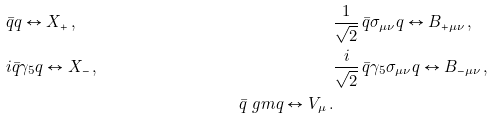Convert formula to latex. <formula><loc_0><loc_0><loc_500><loc_500>& \bar { q } q \leftrightarrow X _ { + } \, , & & \frac { 1 } { \sqrt { 2 } } \, \bar { q } \sigma _ { \mu \nu } q \leftrightarrow B _ { + \mu \nu } \, , \\ & i \bar { q } \gamma _ { 5 } q \leftrightarrow X _ { - } \, , & & \frac { i } { \sqrt { 2 } } \, \bar { q } \gamma _ { 5 } \sigma _ { \mu \nu } q \leftrightarrow B _ { - \mu \nu } \, , \\ & & \bar { q } \ g m q \leftrightarrow V _ { \mu } \, . & &</formula> 